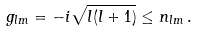<formula> <loc_0><loc_0><loc_500><loc_500>g _ { l m } = - i \sqrt { l ( l + 1 ) } \leq n _ { l m } \, .</formula> 